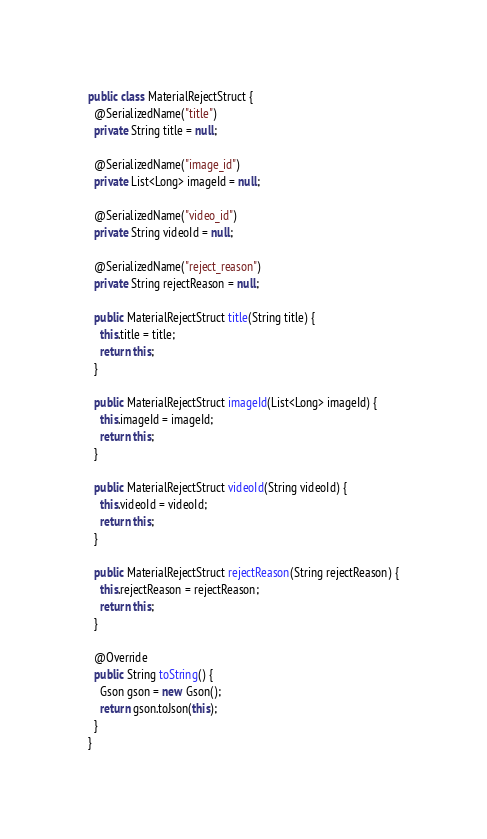Convert code to text. <code><loc_0><loc_0><loc_500><loc_500><_Java_>public class MaterialRejectStruct {
  @SerializedName("title")
  private String title = null;

  @SerializedName("image_id")
  private List<Long> imageId = null;

  @SerializedName("video_id")
  private String videoId = null;

  @SerializedName("reject_reason")
  private String rejectReason = null;

  public MaterialRejectStruct title(String title) {
    this.title = title;
    return this;
  }

  public MaterialRejectStruct imageId(List<Long> imageId) {
    this.imageId = imageId;
    return this;
  }

  public MaterialRejectStruct videoId(String videoId) {
    this.videoId = videoId;
    return this;
  }

  public MaterialRejectStruct rejectReason(String rejectReason) {
    this.rejectReason = rejectReason;
    return this;
  }

  @Override
  public String toString() {
    Gson gson = new Gson();
    return gson.toJson(this);
  }
}
</code> 